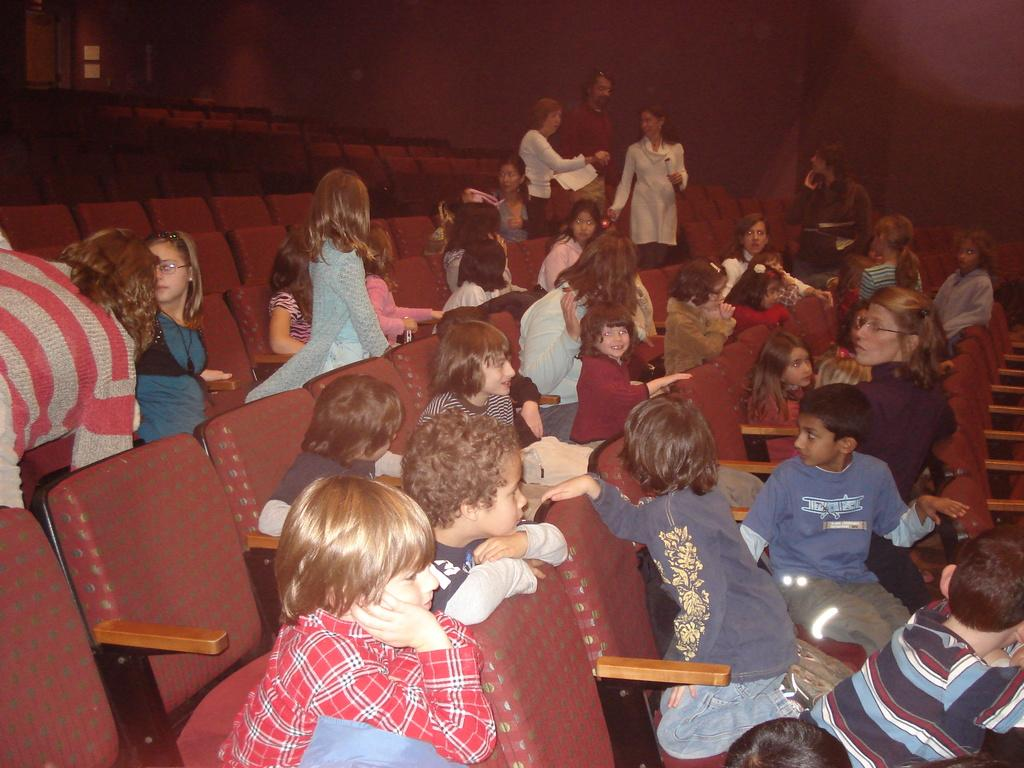Who or what can be seen in the image? There are people in the image. What are the people sitting on in the image? There are chairs in the image. How would you describe the lighting in the image? The background of the image is dark. What else can be seen in the image besides the people and chairs? There are objects visible in the background of the image. What type of ray is swimming in the background of the image? There is no ray present in the image; the background features objects, not marine life. Who is the judge in the image? There is no judge present in the image; the people in the image are not participating in a judicial setting. 